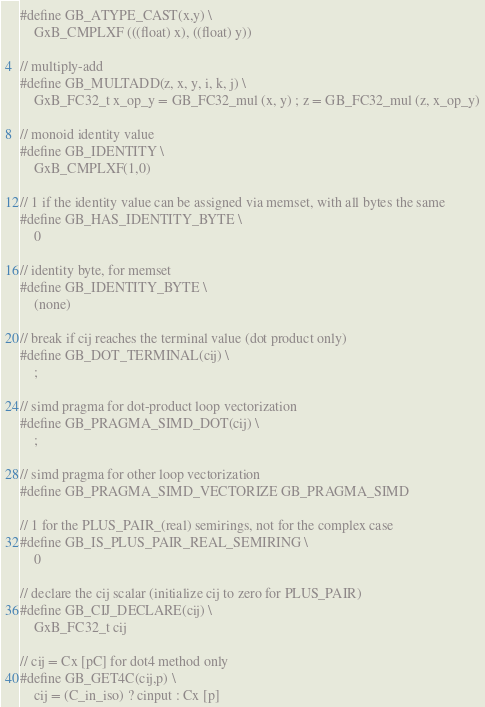Convert code to text. <code><loc_0><loc_0><loc_500><loc_500><_C_>#define GB_ATYPE_CAST(x,y) \
    GxB_CMPLXF (((float) x), ((float) y))

// multiply-add
#define GB_MULTADD(z, x, y, i, k, j) \
    GxB_FC32_t x_op_y = GB_FC32_mul (x, y) ; z = GB_FC32_mul (z, x_op_y)

// monoid identity value
#define GB_IDENTITY \
    GxB_CMPLXF(1,0)

// 1 if the identity value can be assigned via memset, with all bytes the same
#define GB_HAS_IDENTITY_BYTE \
    0

// identity byte, for memset
#define GB_IDENTITY_BYTE \
    (none)

// break if cij reaches the terminal value (dot product only)
#define GB_DOT_TERMINAL(cij) \
    ;

// simd pragma for dot-product loop vectorization
#define GB_PRAGMA_SIMD_DOT(cij) \
    ;

// simd pragma for other loop vectorization
#define GB_PRAGMA_SIMD_VECTORIZE GB_PRAGMA_SIMD

// 1 for the PLUS_PAIR_(real) semirings, not for the complex case
#define GB_IS_PLUS_PAIR_REAL_SEMIRING \
    0

// declare the cij scalar (initialize cij to zero for PLUS_PAIR)
#define GB_CIJ_DECLARE(cij) \
    GxB_FC32_t cij

// cij = Cx [pC] for dot4 method only
#define GB_GET4C(cij,p) \
    cij = (C_in_iso) ? cinput : Cx [p]
</code> 